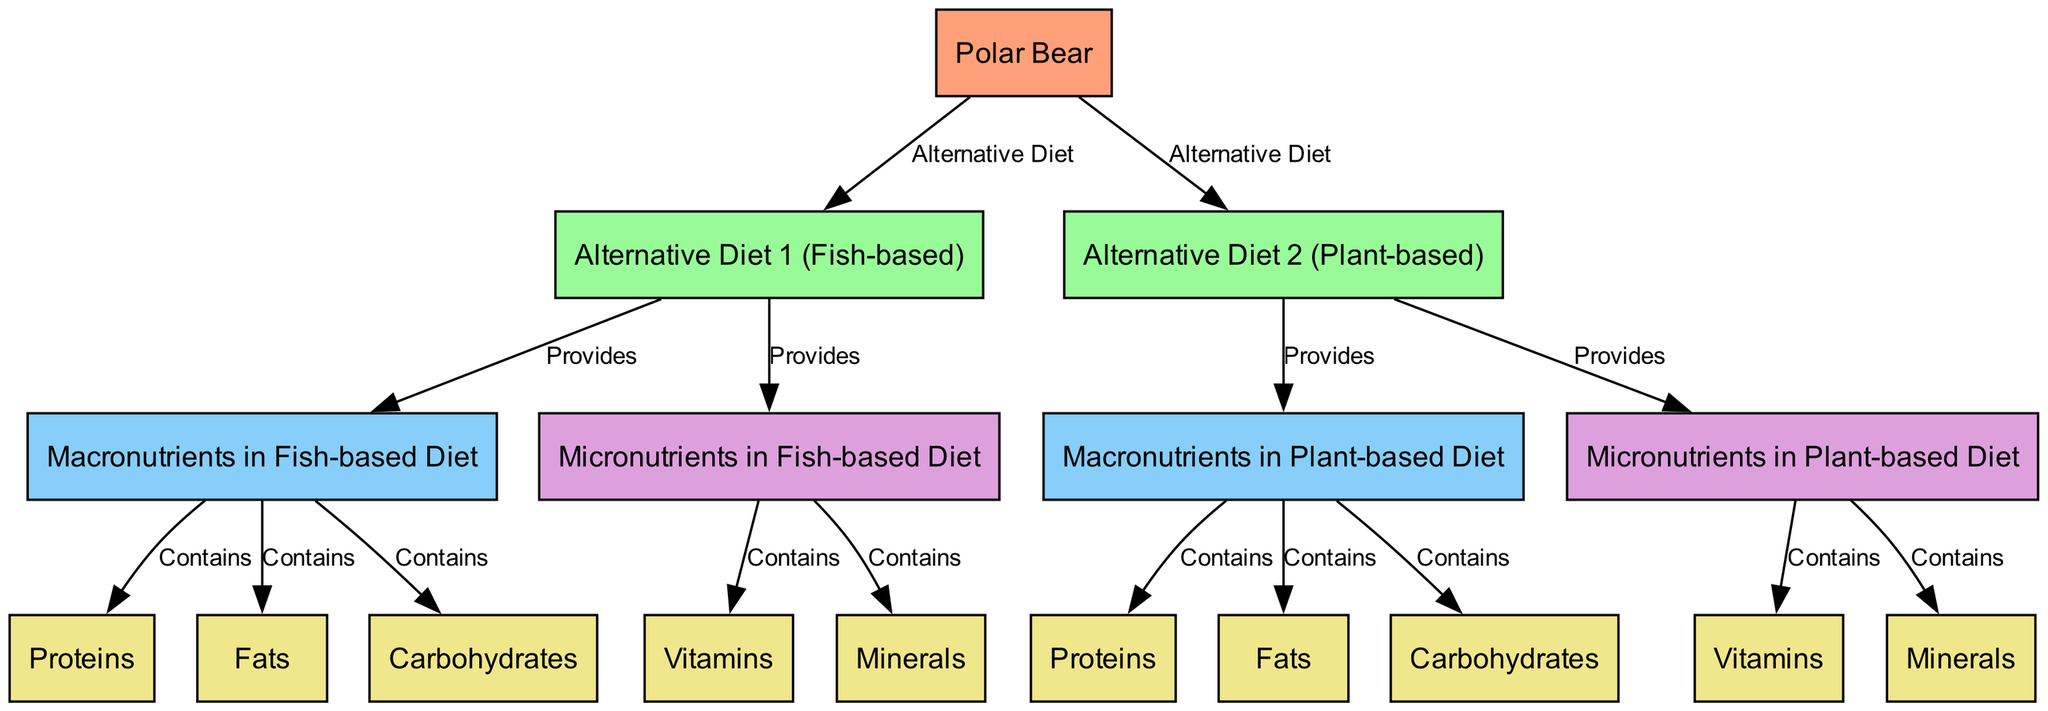What are the two alternative diets for polar bears mentioned in the diagram? The diagram identifies "Alternative Diet 1 (Fish-based)" and "Alternative Diet 2 (Plant-based)" as the two diets. These are labeled as distinct nodes that are directly connected to the "Polar Bear" node, indicating their direct association with the bear's diet.
Answer: Alternative Diet 1 (Fish-based), Alternative Diet 2 (Plant-based) How many macronutrient types are listed for the Fish-based diet? The Fish-based diet is associated with three macronutrient types: Proteins, Fats, and Carbohydrates, which are connected to the "Macronutrients in Fish-based Diet" node. The diagram provides clear connections showing the three distinct categories under macronutrients.
Answer: 3 Which micronutrient is also present in the Fish-based diet? The diagram lists "Vitamins" and "Minerals" under the "Micronutrients in Fish-based Diet." Both are connected as contained elements and reflect the essential micronutrient components attributed to this diet.
Answer: Vitamins, Minerals What do both alternative diets provide for the polar bear? The diagram indicates that both alternative diets provide macronutrients and micronutrients. Each diet is linked to its respective macronutrients and micronutrients nodes, showcasing their role in supplying the nutritional needs of polar bears.
Answer: Macronutrients, Micronutrients Which diet contains more protein according to the diagram? To determine this, one must compare the "Proteins" nodes from both diets. The diagram does not provide specific numerical values for proteins, but each alternative diet has its own proteins node listed separately. Without values given, a definite answer regarding which has more cannot be drawn. However, each diet's nutritional components are distinguished but equally represented.
Answer: Cannot determine How many unique nutrients are included in the Plant-based diet based on the diagram? The "Macronutrients in Plant-based Diet" node contains three types of nutrients: Proteins, Fats, and Carbohydrates, while the "Micronutrients in Plant-based Diet" node includes Vitamins and Minerals. Therefore, by counting the unique nutrients, we find a total of five.
Answer: 5 What relationship connects the polar bear to the fish-based diet? The relationship is labeled as "Alternative Diet," which indicates that the fish-based diet is one option that the polar bear might adapt to as part of its diet. This connection is crucial for understanding dietary adaptations.
Answer: Alternative Diet Which nutrient category contains "Fats" in the Plant-based diet? The diagram shows "Fats" as part of the "Macronutrients in Plant-based Diet" node. This connection demonstrates that fats are included in the macronutrient classification, just like in the fish-based diet.
Answer: Macronutrients 